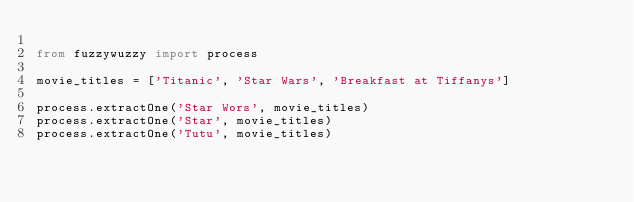<code> <loc_0><loc_0><loc_500><loc_500><_Python_>
from fuzzywuzzy import process

movie_titles = ['Titanic', 'Star Wars', 'Breakfast at Tiffanys']

process.extractOne('Star Wors', movie_titles)
process.extractOne('Star', movie_titles)
process.extractOne('Tutu', movie_titles)
</code> 